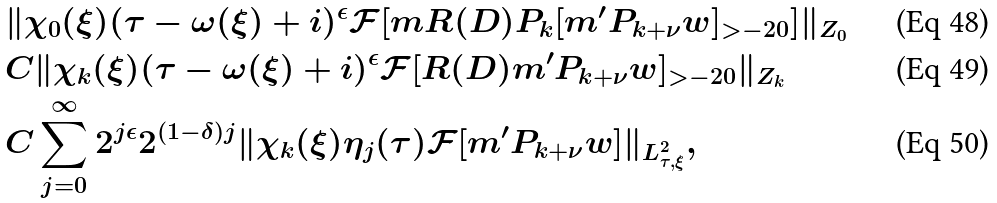Convert formula to latex. <formula><loc_0><loc_0><loc_500><loc_500>& \| \chi _ { 0 } ( \xi ) ( \tau - \omega ( \xi ) + i ) ^ { \epsilon } \mathcal { F } [ m R ( D ) P _ { k } [ m ^ { \prime } P _ { k + \nu } w ] _ { > - 2 0 } ] \| _ { Z _ { 0 } } \\ & C \| \chi _ { k } ( \xi ) ( \tau - \omega ( \xi ) + i ) ^ { \epsilon } \mathcal { F } [ R ( D ) m ^ { \prime } P _ { k + \nu } w ] _ { > - 2 0 } \| _ { Z _ { k } } \\ & C \sum _ { j = 0 } ^ { \infty } 2 ^ { j \epsilon } 2 ^ { ( 1 - \delta ) j } \| \chi _ { k } ( \xi ) \eta _ { j } ( \tau ) \mathcal { F } [ m ^ { \prime } P _ { k + \nu } w ] \| _ { L ^ { 2 } _ { \tau , \xi } } ,</formula> 